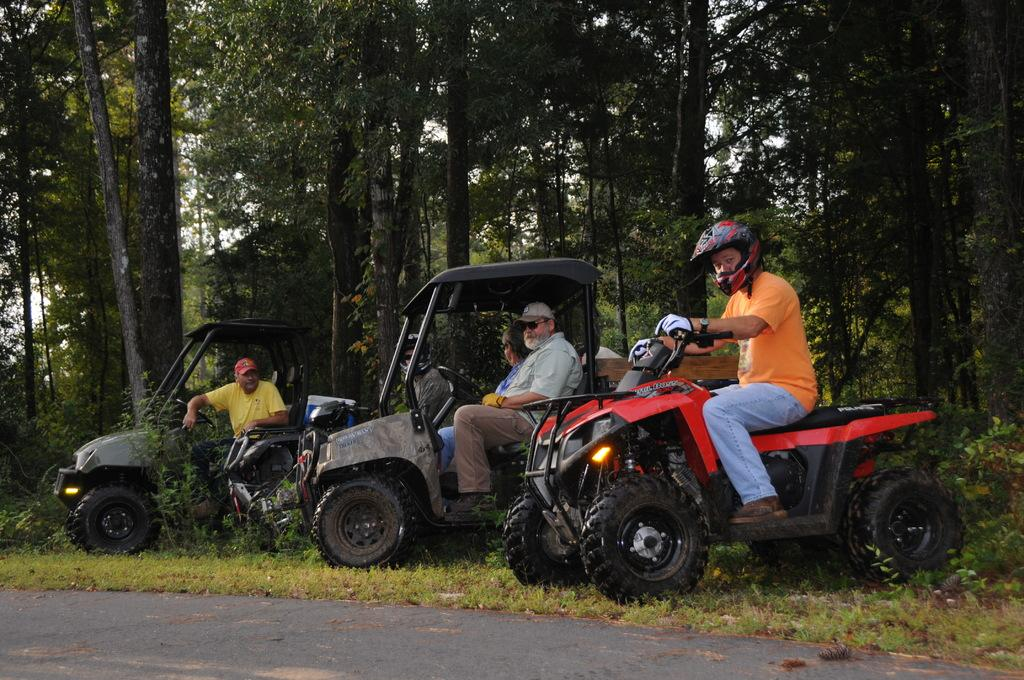What are the people in the image doing? The people in the image are riding a vehicle. Where is the vehicle located? The vehicle is on the grass. What can be seen in the background of the image? There are trees beside the vehicle. What type of clocks can be seen hanging from the trees in the image? There are no clocks visible in the image, and no clocks are hanging from the trees. 